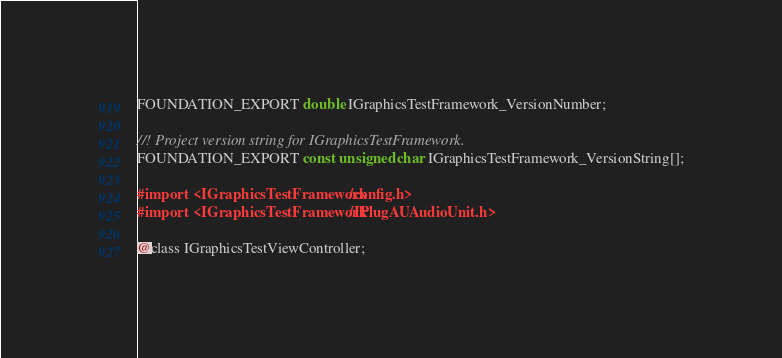<code> <loc_0><loc_0><loc_500><loc_500><_C_>FOUNDATION_EXPORT double IGraphicsTestFramework_VersionNumber;

//! Project version string for IGraphicsTestFramework.
FOUNDATION_EXPORT const unsigned char IGraphicsTestFramework_VersionString[];

#import <IGraphicsTestFramework/config.h>
#import <IGraphicsTestFramework/IPlugAUAudioUnit.h>

@class IGraphicsTestViewController;

</code> 